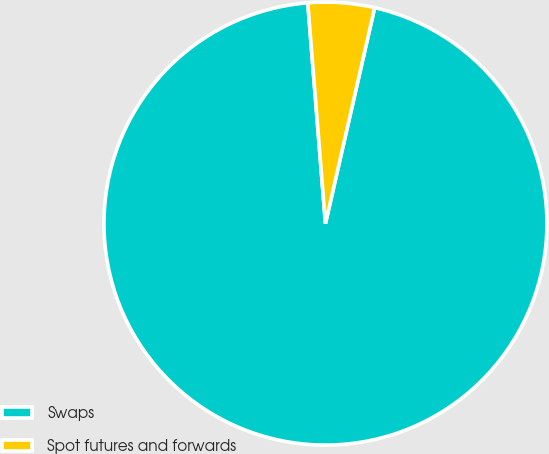<chart> <loc_0><loc_0><loc_500><loc_500><pie_chart><fcel>Swaps<fcel>Spot futures and forwards<nl><fcel>95.16%<fcel>4.84%<nl></chart> 